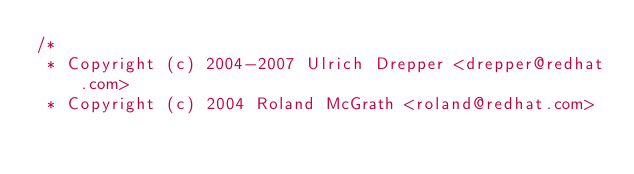Convert code to text. <code><loc_0><loc_0><loc_500><loc_500><_C_>/*
 * Copyright (c) 2004-2007 Ulrich Drepper <drepper@redhat.com>
 * Copyright (c) 2004 Roland McGrath <roland@redhat.com></code> 